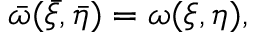Convert formula to latex. <formula><loc_0><loc_0><loc_500><loc_500>\bar { \omega } ( \bar { \xi } , \bar { \eta } ) = \omega ( \xi , \eta ) ,</formula> 